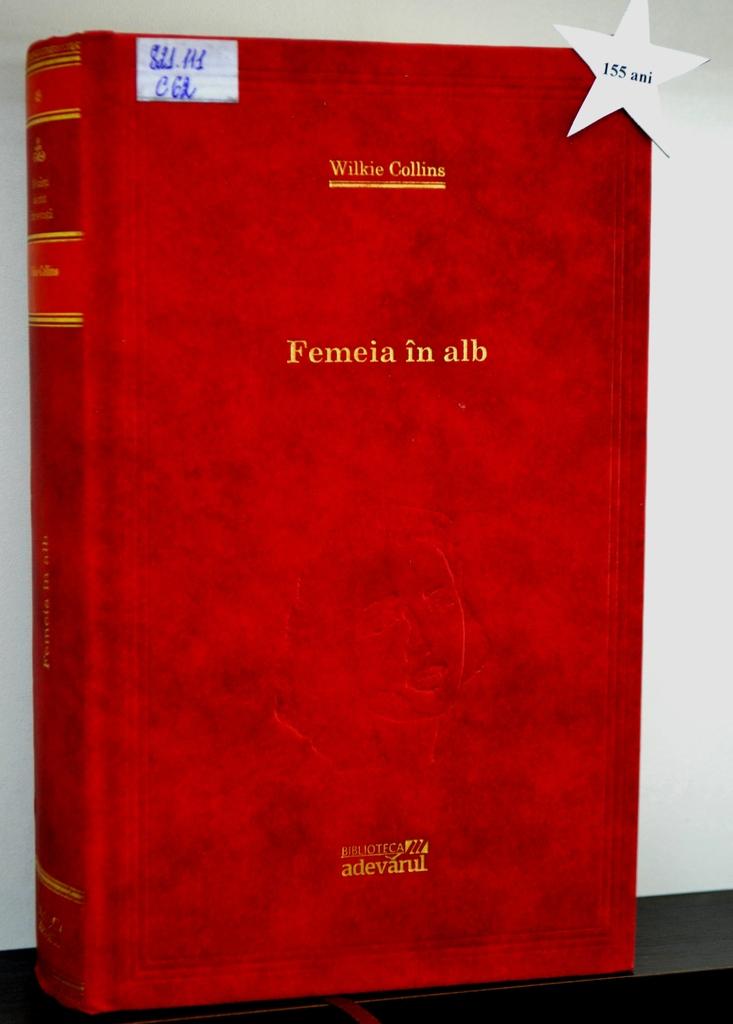What book is this?
Give a very brief answer. Femeia in alb. Who wrote this?
Keep it short and to the point. Wilkie collins. 